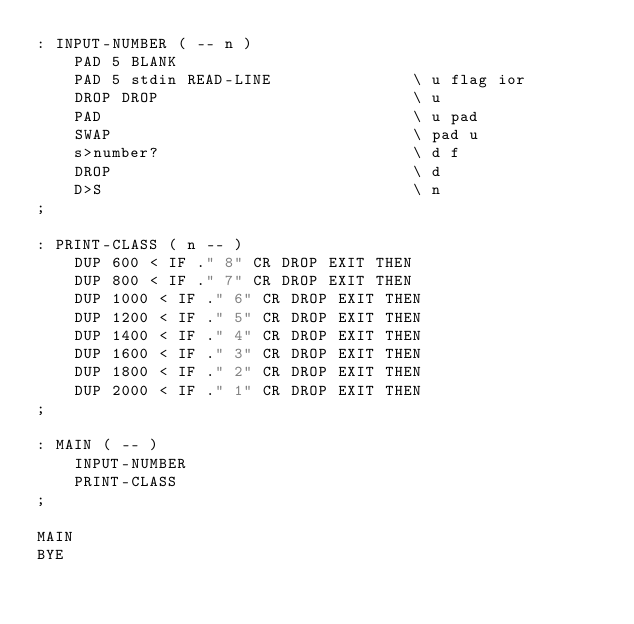Convert code to text. <code><loc_0><loc_0><loc_500><loc_500><_Forth_>: INPUT-NUMBER ( -- n )
    PAD 5 BLANK
    PAD 5 stdin READ-LINE               \ u flag ior
    DROP DROP                           \ u
    PAD                                 \ u pad
    SWAP                                \ pad u
    s>number?                           \ d f
    DROP                                \ d
    D>S                                 \ n
;

: PRINT-CLASS ( n -- )
    DUP 600 < IF ." 8" CR DROP EXIT THEN
    DUP 800 < IF ." 7" CR DROP EXIT THEN
    DUP 1000 < IF ." 6" CR DROP EXIT THEN
    DUP 1200 < IF ." 5" CR DROP EXIT THEN
    DUP 1400 < IF ." 4" CR DROP EXIT THEN
    DUP 1600 < IF ." 3" CR DROP EXIT THEN
    DUP 1800 < IF ." 2" CR DROP EXIT THEN
    DUP 2000 < IF ." 1" CR DROP EXIT THEN
;

: MAIN ( -- )
    INPUT-NUMBER
    PRINT-CLASS
;

MAIN
BYE
</code> 